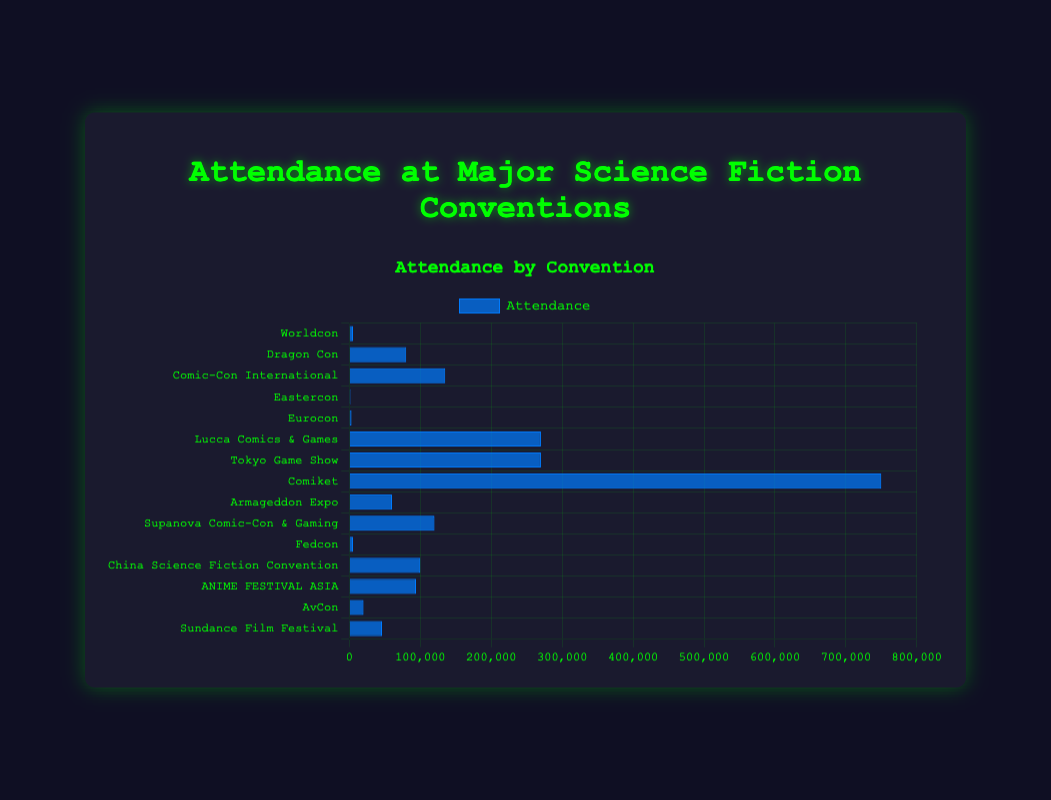What is the most attended convention? The bar chart shows the attendance of each convention. The tallest bar represents the convention with the highest attendance. Comiket has the tallest bar indicating the highest attendance of 750,000.
Answer: Comiket Which region has the convention with the lowest attendance? The bar chart can be visually assessed to find the shortest bar, which corresponds to Eastercon in Europe with an attendance of 1,500.
Answer: Europe What is the combined attendance for all conventions in North America? Summing the attendance numbers for all North American conventions: Worldcon (5,000) + Dragon Con (80,000) + Comic-Con International (135,000) + Sundance Film Festival (46,000) gives 266,000.
Answer: 266,000 How does the attendance of Tokyo Game Show compare to Lucca Comics & Games? Both Tokyo Game Show and Lucca Comics & Games have the same height blue bar representing their attendance. Both have an attendance of 270,000 as seen on the chart.
Answer: Equal Which convention has a higher attendance, Supanova Comic-Con & Gaming or China Science Fiction Convention? By visually comparing the heights of the bars for both conventions, Supanova Comic-Con & Gaming's bar is higher than China Science Fiction Convention. Supanova's attendance is 120,000 compared to China's 100,000.
Answer: Supanova Comic-Con & Gaming What is the average attendance of the conventions in Asia? Sum the attendances of Asian conventions and divide by the number of conventions: 270,000 (Tokyo Game Show) + 750,000 (Comiket) + 100,000 (China Science Fiction Convention) + 94,000 (ANIME FESTIVAL ASIA) = 1,214,000. There are 4 conventions, so the average is 1,214,000 / 4 = 303,500.
Answer: 303,500 Which convention has the second-highest attendance? Looking at the heights of the bars in descending order, Comiket has the highest attendance and the next highest bar is for Lucca Comics & Games with an attendance of 270,000.
Answer: Lucca Comics & Games What is the difference between the highest and lowest attended conventions? The highest attended convention is Comiket (750,000) and the lowest attended is Eastercon (1,500). The difference is 750,000 - 1,500 = 748,500.
Answer: 748,500 How many conventions have attendances greater than 100,000? By visually assessing the bar chart, the conventions with attendance greater than 100,000 are Comic-Con International, Tokyo Game Show, Comiket, Supanova Comic-Con & Gaming, and ANIME FESTIVAL ASIA, totaling 5.
Answer: 5 